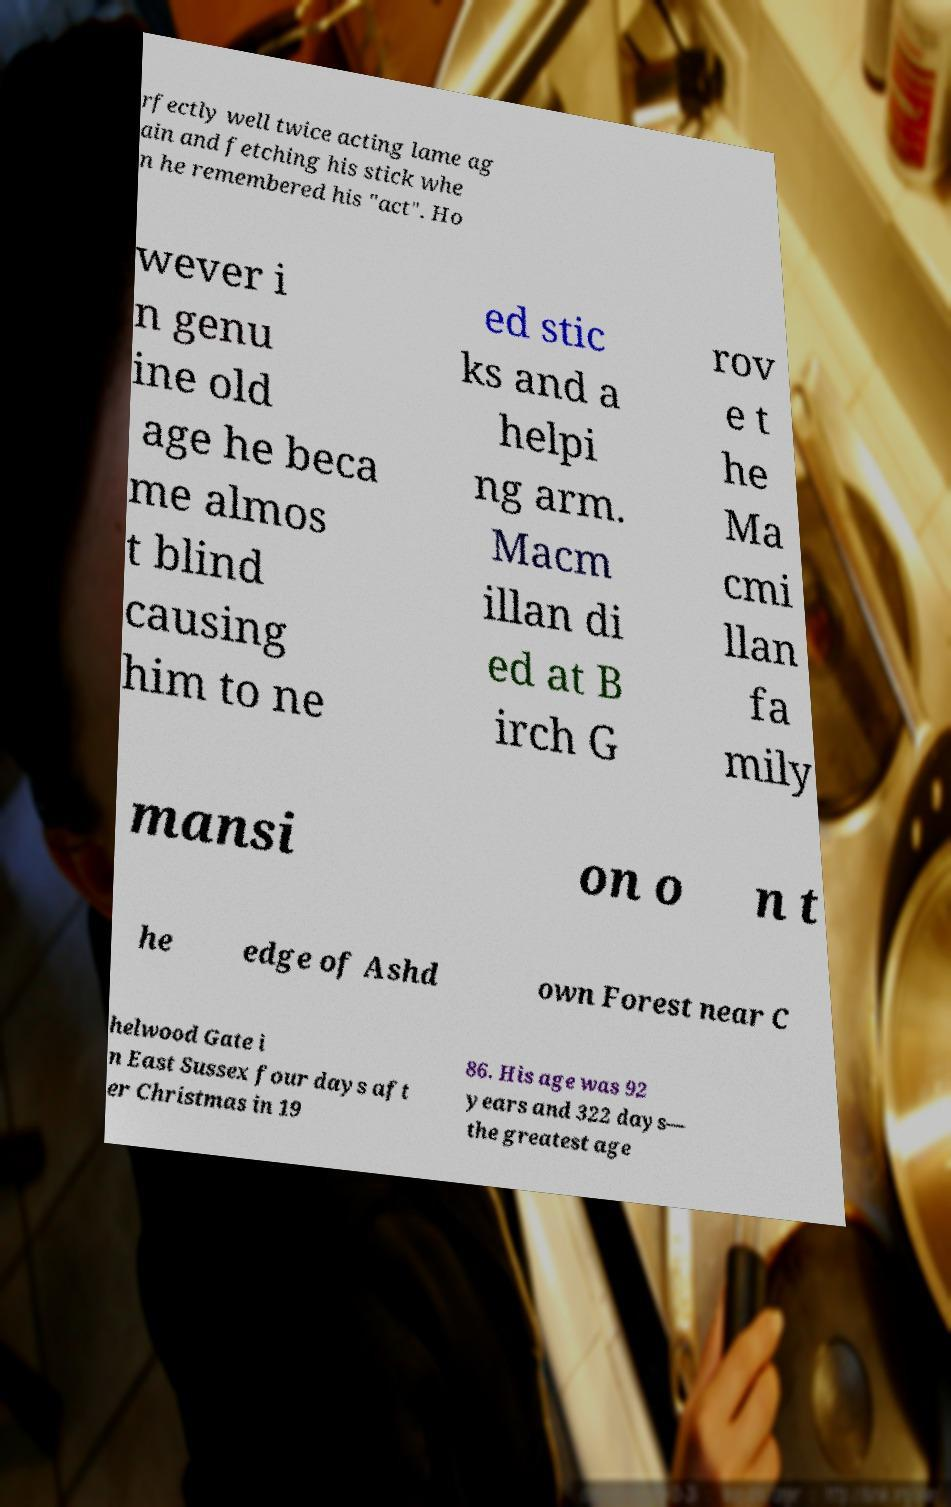There's text embedded in this image that I need extracted. Can you transcribe it verbatim? rfectly well twice acting lame ag ain and fetching his stick whe n he remembered his "act". Ho wever i n genu ine old age he beca me almos t blind causing him to ne ed stic ks and a helpi ng arm. Macm illan di ed at B irch G rov e t he Ma cmi llan fa mily mansi on o n t he edge of Ashd own Forest near C helwood Gate i n East Sussex four days aft er Christmas in 19 86. His age was 92 years and 322 days— the greatest age 